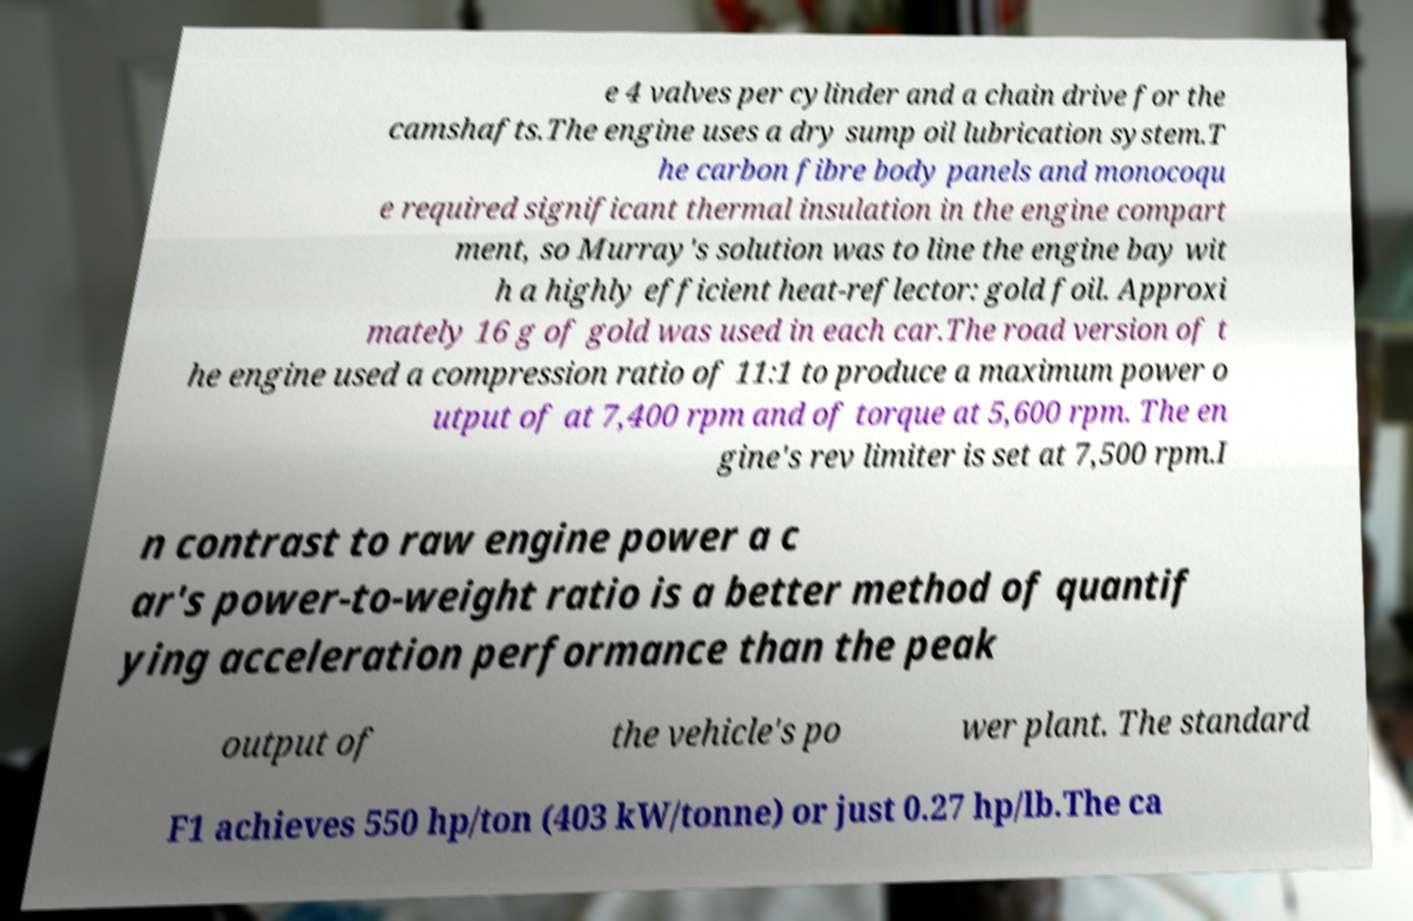For documentation purposes, I need the text within this image transcribed. Could you provide that? e 4 valves per cylinder and a chain drive for the camshafts.The engine uses a dry sump oil lubrication system.T he carbon fibre body panels and monocoqu e required significant thermal insulation in the engine compart ment, so Murray's solution was to line the engine bay wit h a highly efficient heat-reflector: gold foil. Approxi mately 16 g of gold was used in each car.The road version of t he engine used a compression ratio of 11:1 to produce a maximum power o utput of at 7,400 rpm and of torque at 5,600 rpm. The en gine's rev limiter is set at 7,500 rpm.I n contrast to raw engine power a c ar's power-to-weight ratio is a better method of quantif ying acceleration performance than the peak output of the vehicle's po wer plant. The standard F1 achieves 550 hp/ton (403 kW/tonne) or just 0.27 hp/lb.The ca 